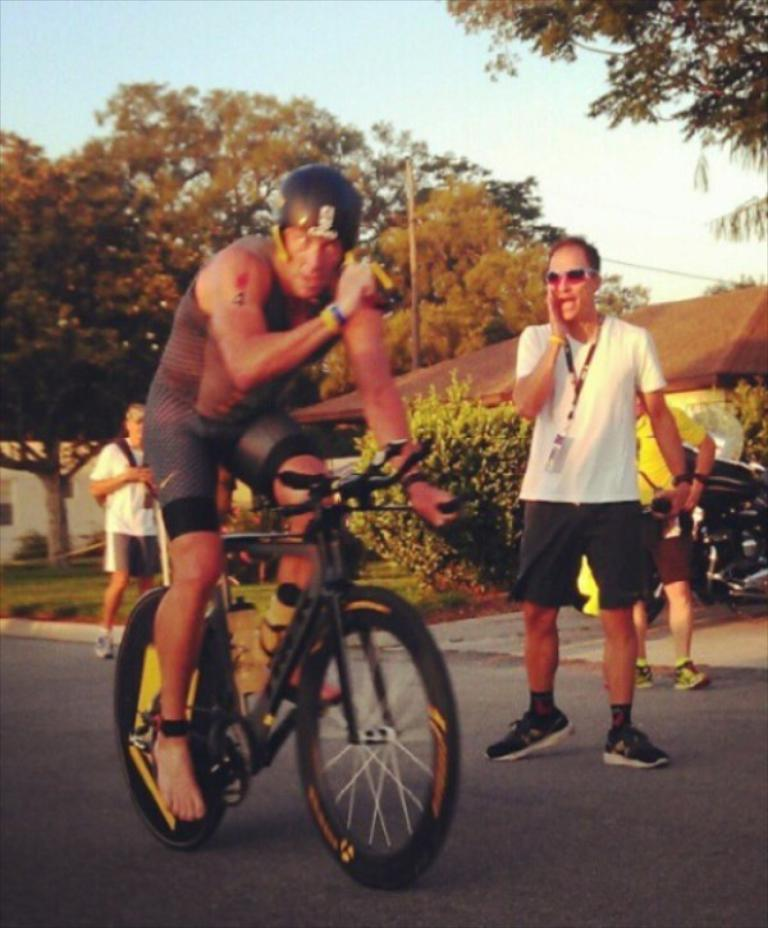What is happening in the image involving a group of people? There is a group of people in the image, but their specific activity is not mentioned in the facts. What is the man doing in the image? The man is riding a bicycle on the road. What type of vegetation can be seen in the image? There are trees in the image. What type of structure is present in the image? There is a house in the image. What type of error can be seen in the image? There is no mention of an error in the image, as the facts provided do not indicate any mistakes or issues. What channel is the man watching while riding his bicycle? There is no mention of a television or channel in the image, as the facts provided focus on the man riding a bicycle and the presence of a group of people, trees, and a house. 